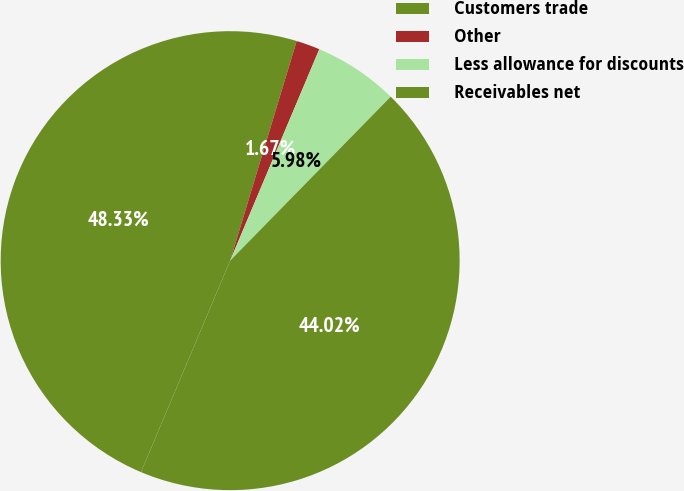Convert chart to OTSL. <chart><loc_0><loc_0><loc_500><loc_500><pie_chart><fcel>Customers trade<fcel>Other<fcel>Less allowance for discounts<fcel>Receivables net<nl><fcel>48.33%<fcel>1.67%<fcel>5.98%<fcel>44.02%<nl></chart> 